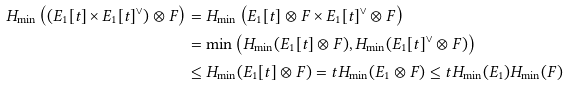Convert formula to latex. <formula><loc_0><loc_0><loc_500><loc_500>H _ { \min } \left ( ( E _ { 1 } [ t ] \times E _ { 1 } [ t ] ^ { \vee } ) \otimes F \right ) & = H _ { \min } \left ( E _ { 1 } [ t ] \otimes F \times E _ { 1 } [ t ] ^ { \vee } \otimes F \right ) \\ & = \min \left ( H _ { \min } ( E _ { 1 } [ t ] \otimes F ) , H _ { \min } ( E _ { 1 } [ t ] ^ { \vee } \otimes F ) \right ) \\ & \leq H _ { \min } ( E _ { 1 } [ t ] \otimes F ) = t H _ { \min } ( E _ { 1 } \otimes F ) \leq t H _ { \min } ( E _ { 1 } ) H _ { \min } ( F )</formula> 